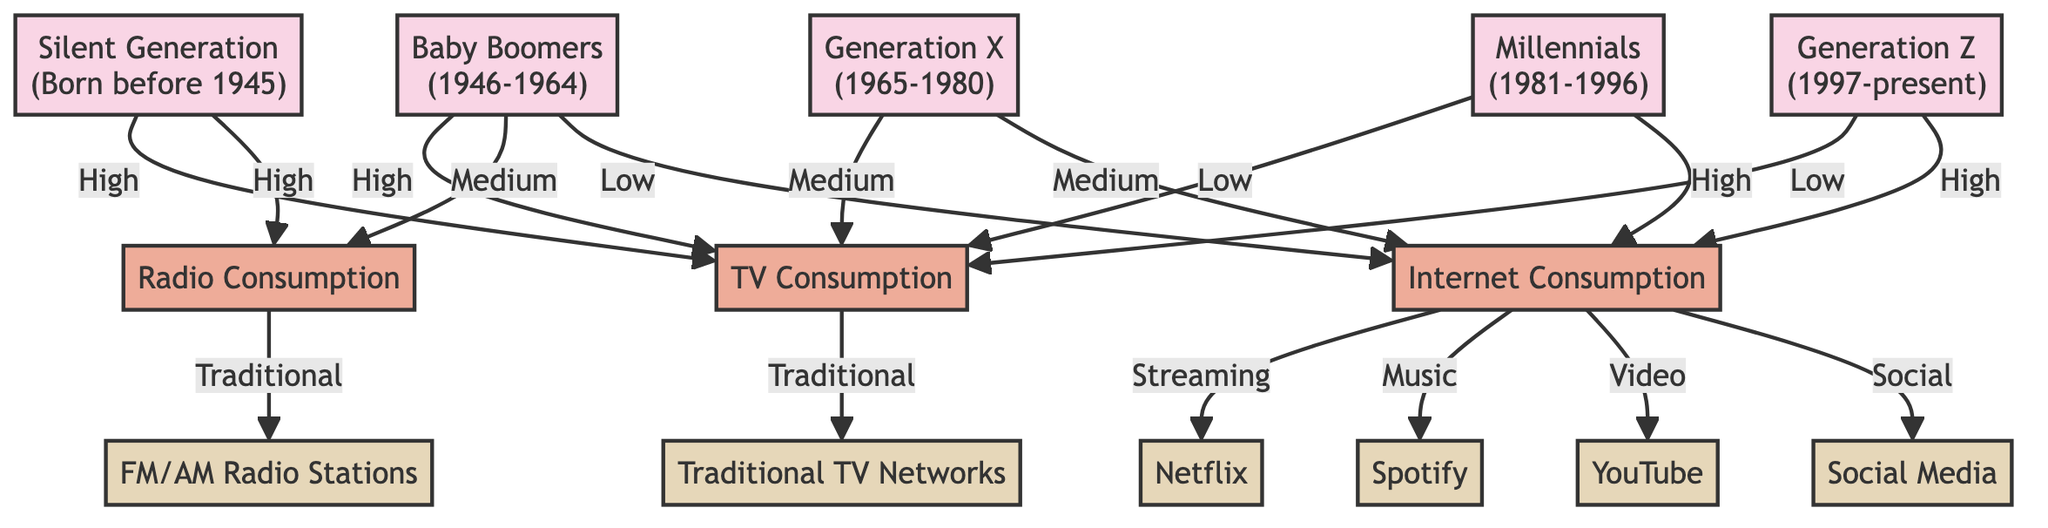What is the media consumption type associated with Generation Z? Generation Z is primarily associated with high Internet consumption, as shown in the diagram where they have a direct high relationship with the Internet Consumption node.
Answer: Internet Consumption Which generation has the highest TV consumption? The diagram shows that both the Silent Generation and Baby Boomers have a high relationship with TV Consumption, but the Silent Generation predates Baby Boomers, indicating they likely have the highest TV consumption.
Answer: Silent Generation How many media types are represented in the diagram? The diagram depicts three primary media types: TV Consumption, Radio Consumption, and Internet Consumption; thus, there are a total of three media types.
Answer: 3 Which generation has the lowest consumption of traditional radio? By analyzing the relationships, Generation Z shows low consumption in Internet Consumption and no explicit linkage to Radio Consumption, indicating they have the least interest in traditional radio; hence, they likely have the lowest.
Answer: Generation Z What is the primary platform for Internet consumption for Millennials? The diagram reflects that for Internet consumption, Millennials primarily engage through platforms such as YouTube for video streaming. This suggests that YouTube serves as the primary platform for this generation.
Answer: YouTube Which two generations have the same medium level of radio consumption? The Baby Boomers and Generation X exhibit medium levels of Radio Consumption in the diagram, implying they share similar consumption patterns within that media type.
Answer: Baby Boomers and Generation X What streaming service is linked to Internet consumption? The diagram directly connects Netflix to Internet Consumption as a streaming service, indicating its relevance to the media behavior in that category.
Answer: Netflix Which media type is favored by the Baby Boomers for consumption? The diagram illustrates that Baby Boomers favor TV Consumption since they have a high association with it compared to other media types.
Answer: TV Consumption Which generation has the highest engagement with Social Media? Examining the relationships, Generation Z has high Internet Consumption, which connects to Social Media platforms; thus, they are identified as the generation with the highest engagement in that area.
Answer: Generation Z 